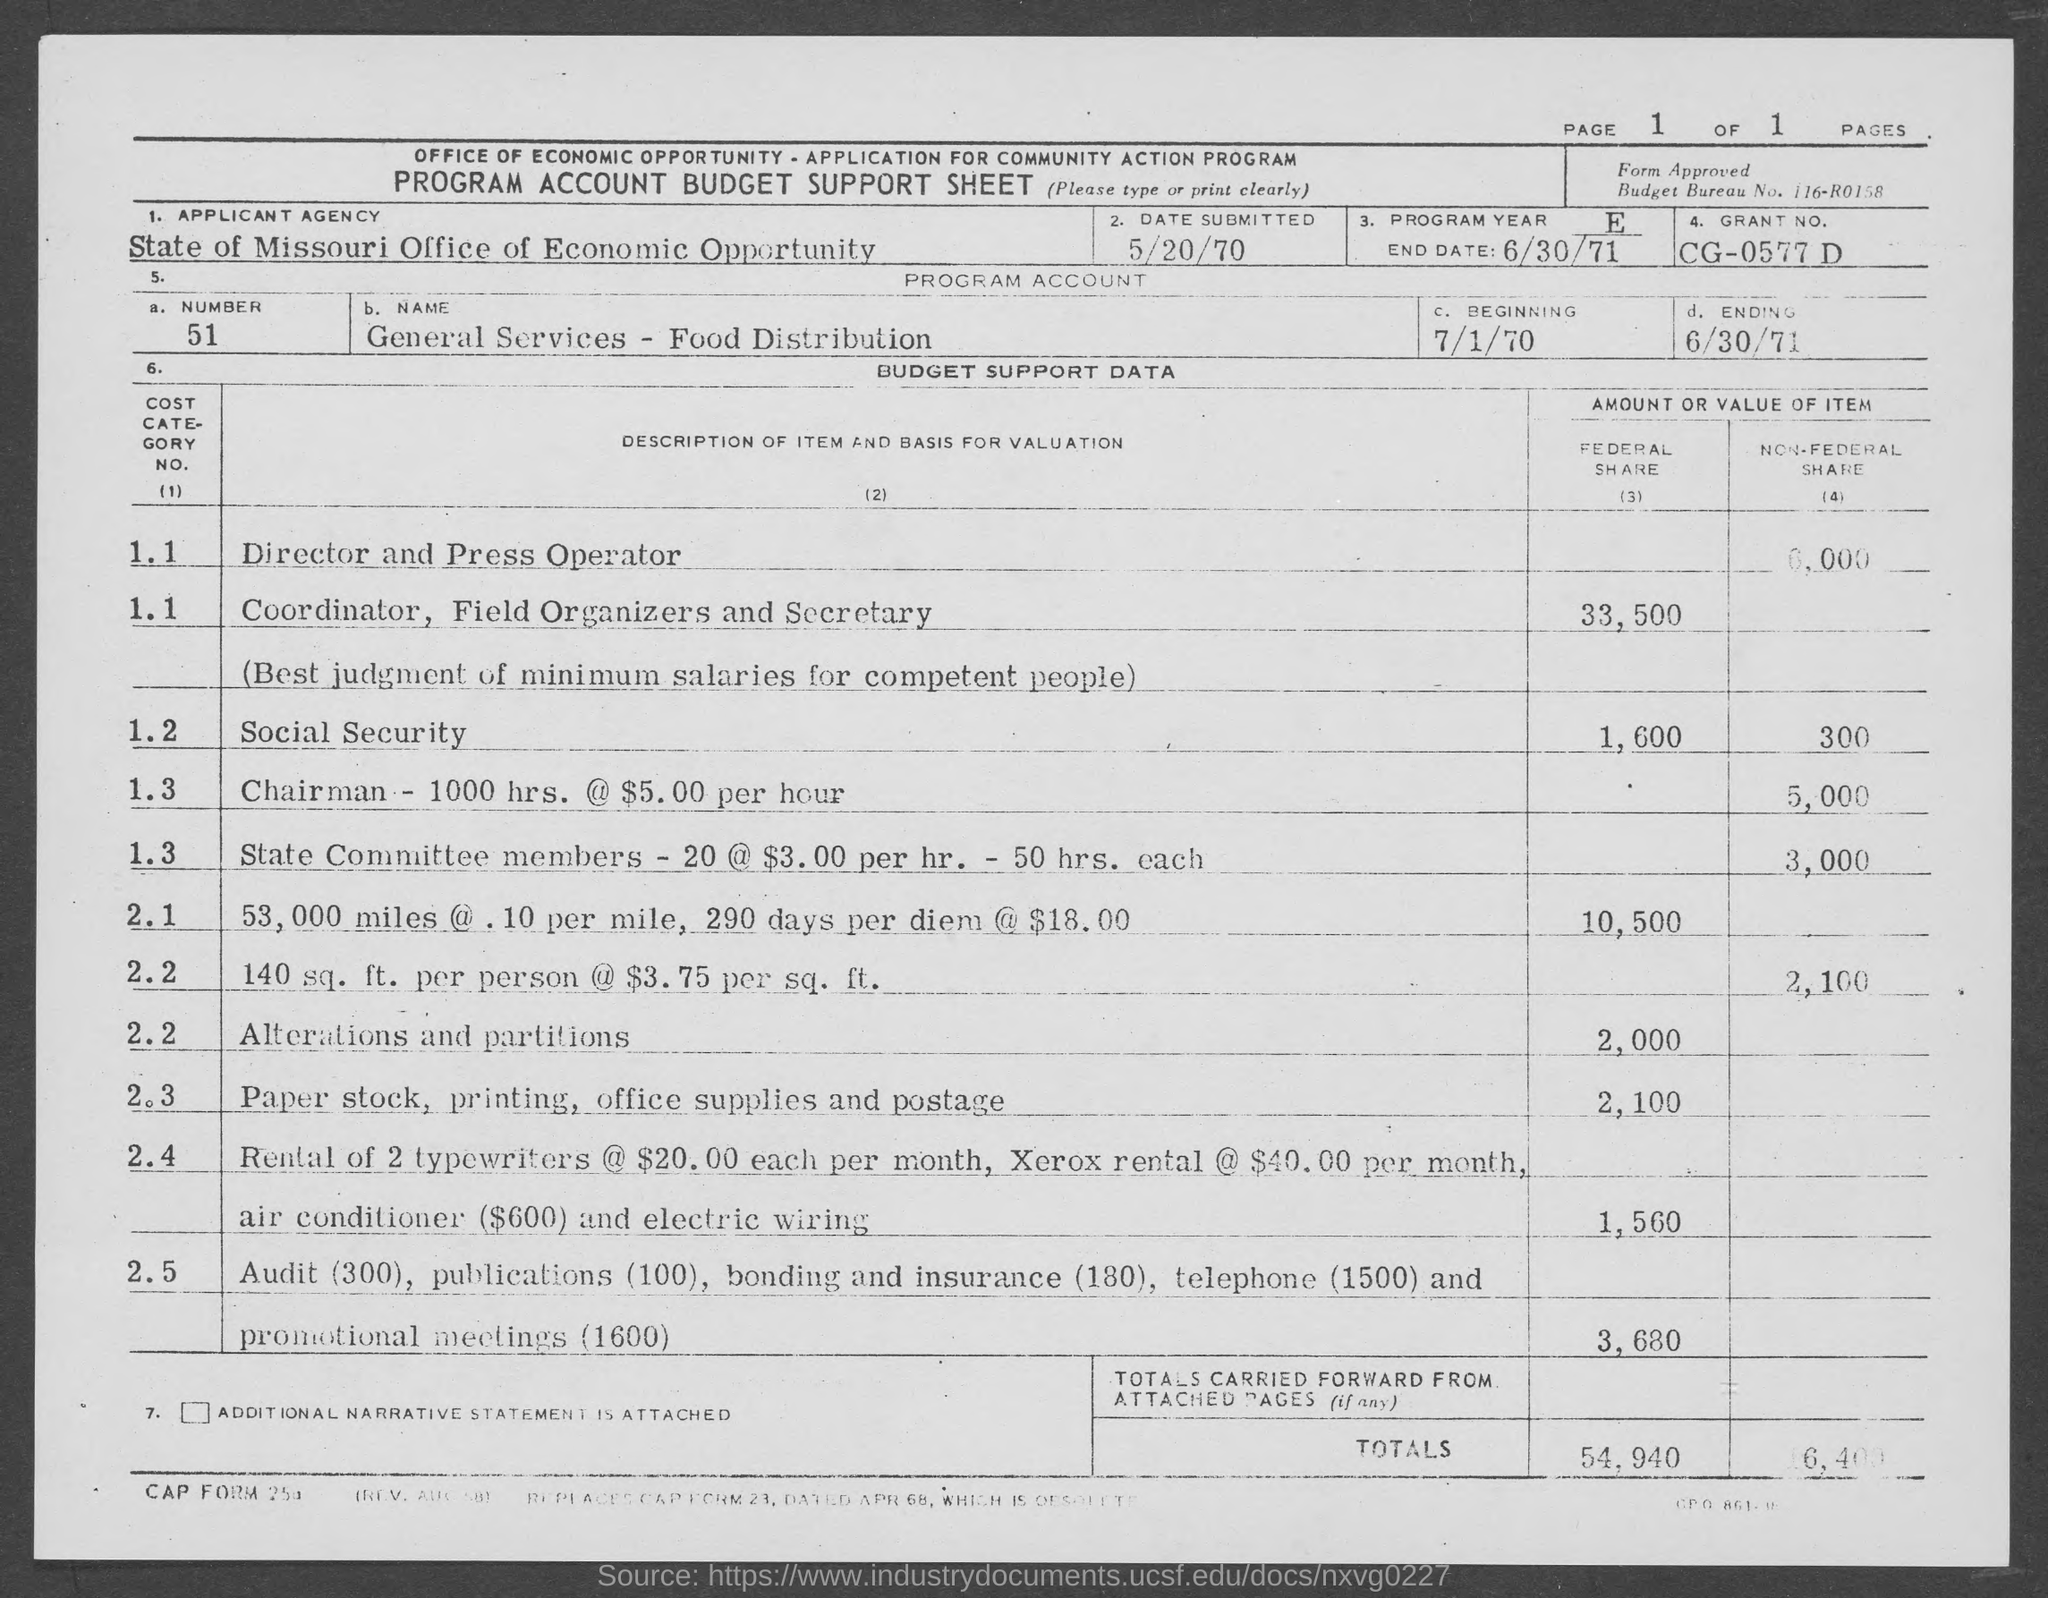Outline some significant characteristics in this image. On June 30, 1971, the program will come to an end. The applicant agency is the State of Missouri Office of Economic Opportunity. The program account number is 51. The program account's beginning date is July 1, 1970. 